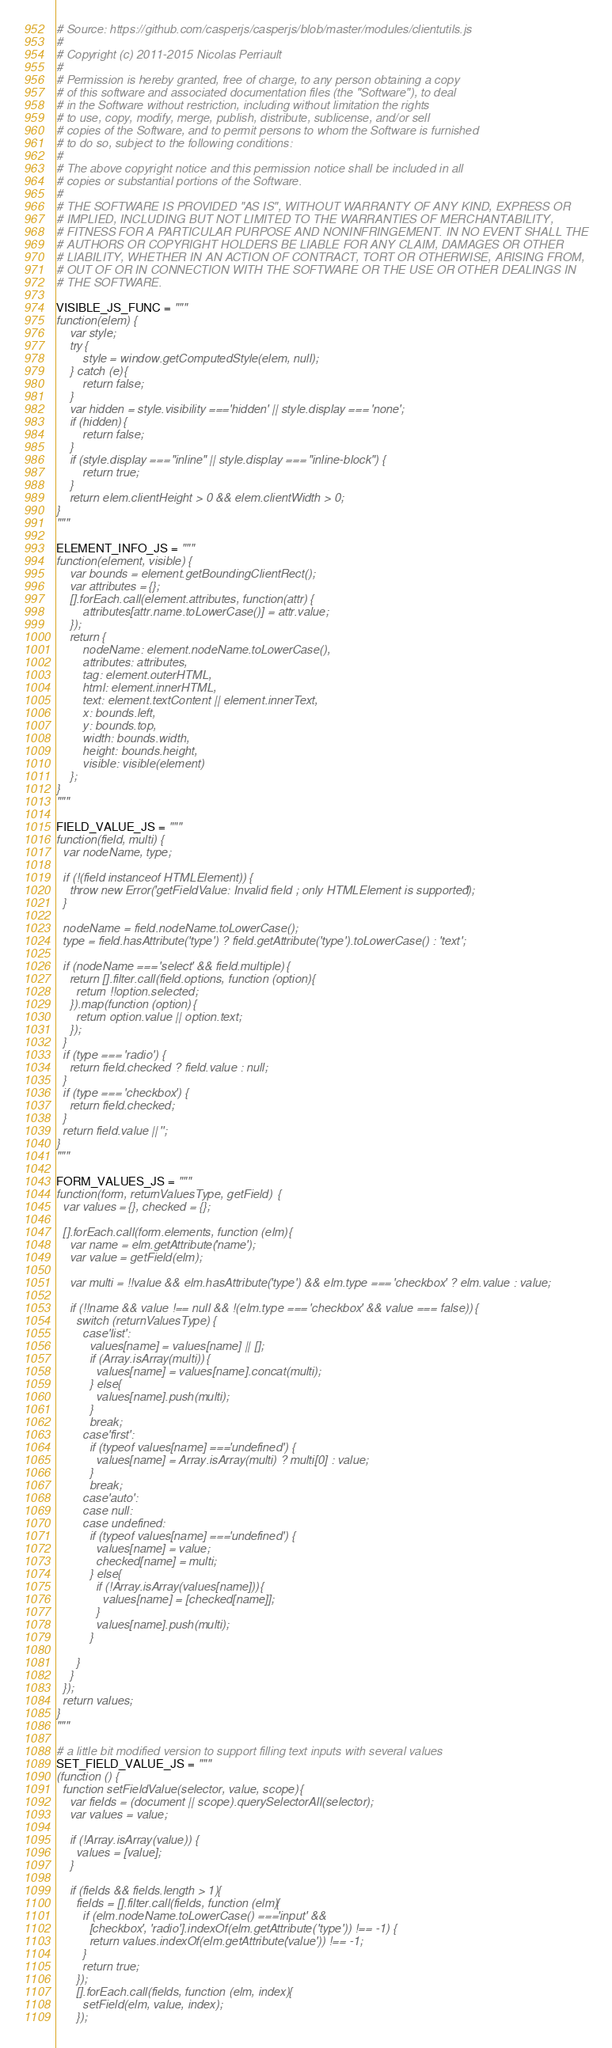<code> <loc_0><loc_0><loc_500><loc_500><_Python_># Source: https://github.com/casperjs/casperjs/blob/master/modules/clientutils.js
#
# Copyright (c) 2011-2015 Nicolas Perriault
#
# Permission is hereby granted, free of charge, to any person obtaining a copy
# of this software and associated documentation files (the "Software"), to deal
# in the Software without restriction, including without limitation the rights
# to use, copy, modify, merge, publish, distribute, sublicense, and/or sell
# copies of the Software, and to permit persons to whom the Software is furnished
# to do so, subject to the following conditions:
#
# The above copyright notice and this permission notice shall be included in all
# copies or substantial portions of the Software.
#
# THE SOFTWARE IS PROVIDED "AS IS", WITHOUT WARRANTY OF ANY KIND, EXPRESS OR
# IMPLIED, INCLUDING BUT NOT LIMITED TO THE WARRANTIES OF MERCHANTABILITY,
# FITNESS FOR A PARTICULAR PURPOSE AND NONINFRINGEMENT. IN NO EVENT SHALL THE
# AUTHORS OR COPYRIGHT HOLDERS BE LIABLE FOR ANY CLAIM, DAMAGES OR OTHER
# LIABILITY, WHETHER IN AN ACTION OF CONTRACT, TORT OR OTHERWISE, ARISING FROM,
# OUT OF OR IN CONNECTION WITH THE SOFTWARE OR THE USE OR OTHER DEALINGS IN
# THE SOFTWARE.

VISIBLE_JS_FUNC = """
function(elem) {
    var style;
    try {
        style = window.getComputedStyle(elem, null);
    } catch (e) {
        return false;
    }
    var hidden = style.visibility === 'hidden' || style.display === 'none';
    if (hidden) {
        return false;
    }
    if (style.display === "inline" || style.display === "inline-block") {
        return true;
    }
    return elem.clientHeight > 0 && elem.clientWidth > 0;
}
"""

ELEMENT_INFO_JS = """
function(element, visible) {
    var bounds = element.getBoundingClientRect();
    var attributes = {};
    [].forEach.call(element.attributes, function(attr) {
        attributes[attr.name.toLowerCase()] = attr.value;
    });
    return {
        nodeName: element.nodeName.toLowerCase(),
        attributes: attributes,
        tag: element.outerHTML,
        html: element.innerHTML,
        text: element.textContent || element.innerText,
        x: bounds.left,
        y: bounds.top,
        width: bounds.width,
        height: bounds.height,
        visible: visible(element)
    };
}
"""

FIELD_VALUE_JS = """
function(field, multi) {
  var nodeName, type;

  if (!(field instanceof HTMLElement)) {
    throw new Error('getFieldValue: Invalid field ; only HTMLElement is supported');
  }

  nodeName = field.nodeName.toLowerCase();
  type = field.hasAttribute('type') ? field.getAttribute('type').toLowerCase() : 'text';

  if (nodeName === 'select' && field.multiple) {
    return [].filter.call(field.options, function (option) {
      return !!option.selected;
    }).map(function (option) {
      return option.value || option.text;
    });
  }
  if (type === 'radio') {
    return field.checked ? field.value : null;
  }
  if (type === 'checkbox') {
    return field.checked;
  }
  return field.value || '';
}
"""

FORM_VALUES_JS = """
function(form, returnValuesType, getField) {
  var values = {}, checked = {};

  [].forEach.call(form.elements, function (elm) {
    var name = elm.getAttribute('name');
    var value = getField(elm);

    var multi = !!value && elm.hasAttribute('type') && elm.type === 'checkbox' ? elm.value : value;

    if (!!name && value !== null && !(elm.type === 'checkbox' && value === false)) {
      switch (returnValuesType) {
        case 'list':
          values[name] = values[name] || [];
          if (Array.isArray(multi)) {
            values[name] = values[name].concat(multi);
          } else {
            values[name].push(multi);
          }
          break;
        case 'first':
          if (typeof values[name] === 'undefined') {
            values[name] = Array.isArray(multi) ? multi[0] : value;
          }
          break;
        case 'auto':
        case null:
        case undefined:
          if (typeof values[name] === 'undefined') {
            values[name] = value;
            checked[name] = multi;
          } else {
            if (!Array.isArray(values[name])) {
              values[name] = [checked[name]];
            }
            values[name].push(multi);
          }

      }
    }
  });
  return values;
}
"""

# a little bit modified version to support filling text inputs with several values
SET_FIELD_VALUE_JS = """
(function () {
  function setFieldValue(selector, value, scope) {
    var fields = (document || scope).querySelectorAll(selector);
    var values = value;

    if (!Array.isArray(value)) {
      values = [value];
    }

    if (fields && fields.length > 1) {
      fields = [].filter.call(fields, function (elm) {
        if (elm.nodeName.toLowerCase() === 'input' &&
          ['checkbox', 'radio'].indexOf(elm.getAttribute('type')) !== -1) {
          return values.indexOf(elm.getAttribute('value')) !== -1;
        }
        return true;
      });
      [].forEach.call(fields, function (elm, index) {
        setField(elm, value, index);
      });</code> 